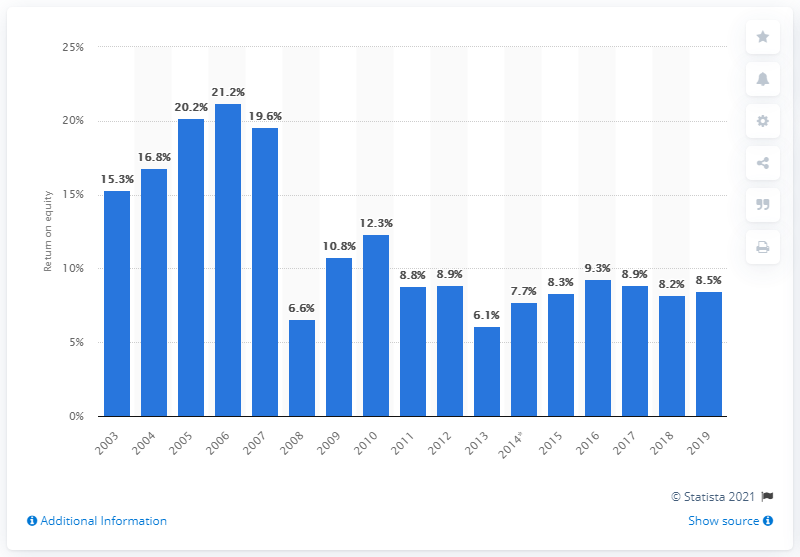List a handful of essential elements in this visual. The return on equity (ROE) of BNP Paribas in 2019 was 8.5%. 